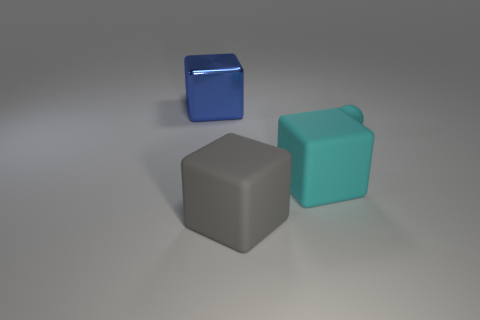What material is the big cube in front of the large object right of the rubber cube left of the cyan cube?
Ensure brevity in your answer.  Rubber. Does the large cube behind the cyan cube have the same material as the cyan ball?
Ensure brevity in your answer.  No. What number of cyan rubber things have the same size as the blue shiny block?
Your answer should be compact. 1. Are there more large blue cubes that are right of the big blue object than tiny cyan spheres in front of the gray matte thing?
Provide a short and direct response. No. Are there any other tiny cyan things of the same shape as the tiny cyan rubber object?
Provide a succinct answer. No. There is a rubber object to the right of the cyan rubber object that is in front of the tiny cyan ball; how big is it?
Offer a very short reply. Small. There is a large matte thing to the right of the block in front of the large matte object that is to the right of the large gray matte object; what is its shape?
Ensure brevity in your answer.  Cube. What is the size of the sphere that is made of the same material as the big gray object?
Make the answer very short. Small. Is the number of cyan things greater than the number of large cyan balls?
Ensure brevity in your answer.  Yes. What material is the gray cube that is the same size as the cyan matte block?
Ensure brevity in your answer.  Rubber. 